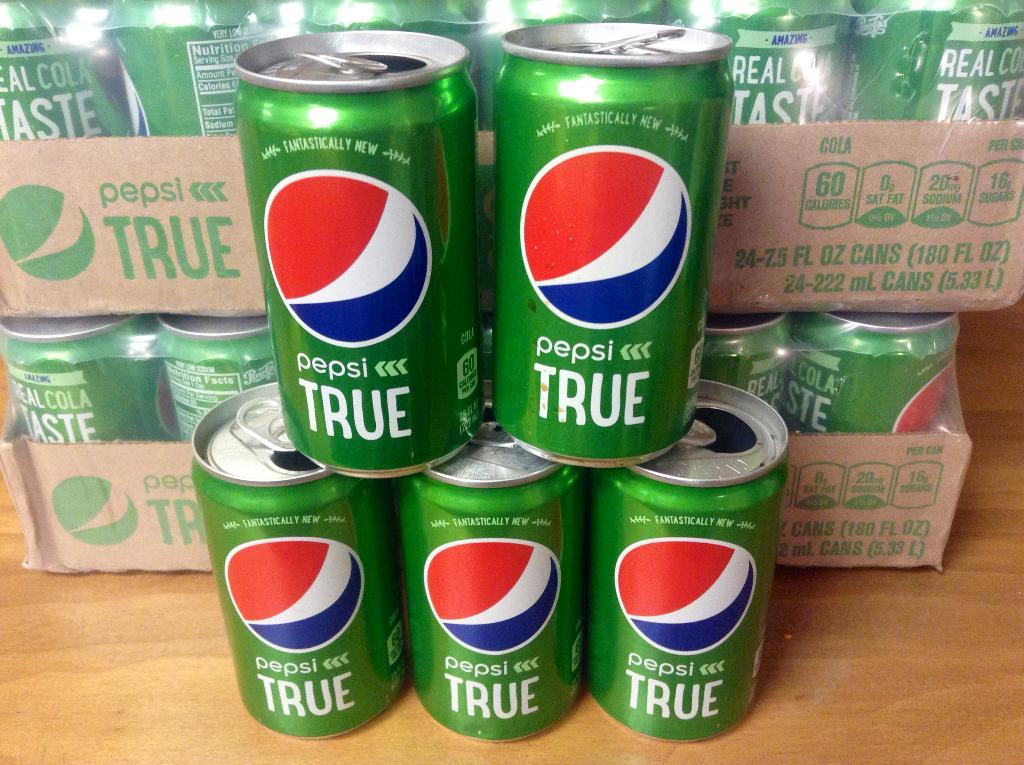Provide a one-sentence caption for the provided image. a stack of green and blue pepsi true soda cans. 